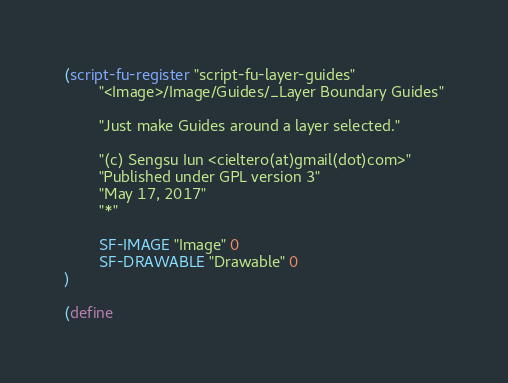<code> <loc_0><loc_0><loc_500><loc_500><_Scheme_>(script-fu-register "script-fu-layer-guides"
        "<Image>/Image/Guides/_Layer Boundary Guides"

        "Just make Guides around a layer selected."

        "(c) Sengsu Iun <cieltero(at)gmail(dot)com>"
        "Published under GPL version 3"
        "May 17, 2017"
        "*"

        SF-IMAGE "Image" 0
        SF-DRAWABLE "Drawable" 0
)

(define</code> 